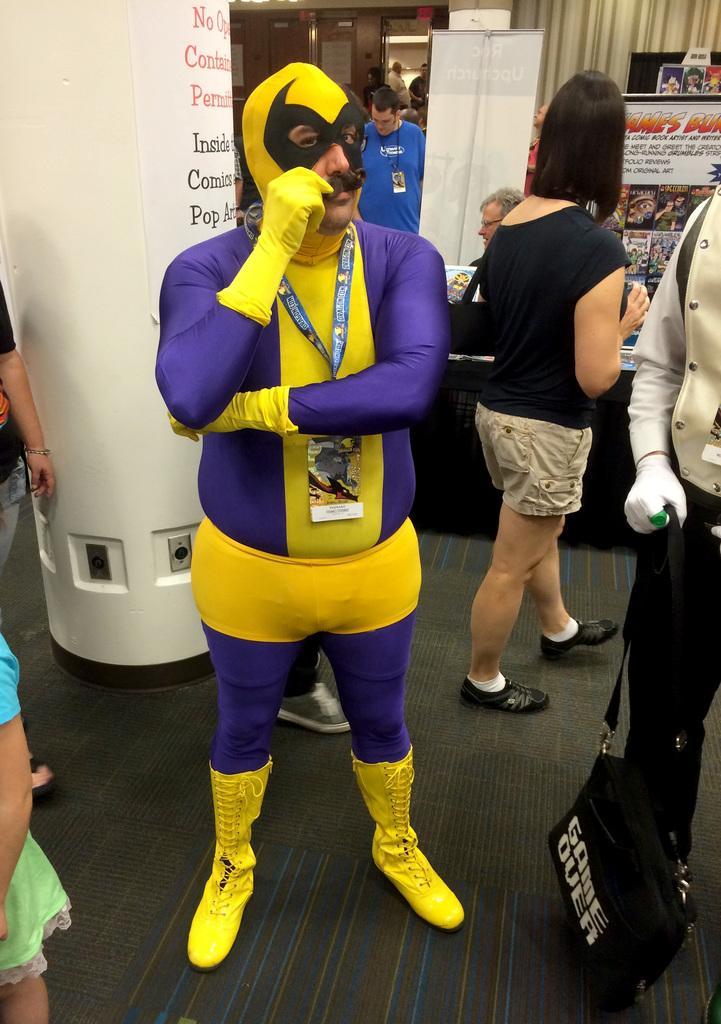Please provide a concise description of this image. In the center of the image we can see a man wearing a costume and standing on the floor. Image also consists of a few people. In the background we can see the banner, frames, pillar and there is a paper with text attached to the pillar. We can also see the curtain. 